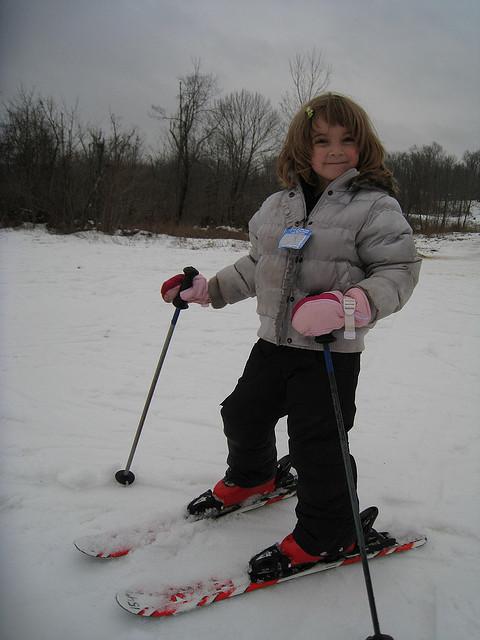Does the little girl like skiing?
Be succinct. Yes. What color are her mittens?
Concise answer only. Pink. Is this picture taken in North Dakota?
Concise answer only. No. 